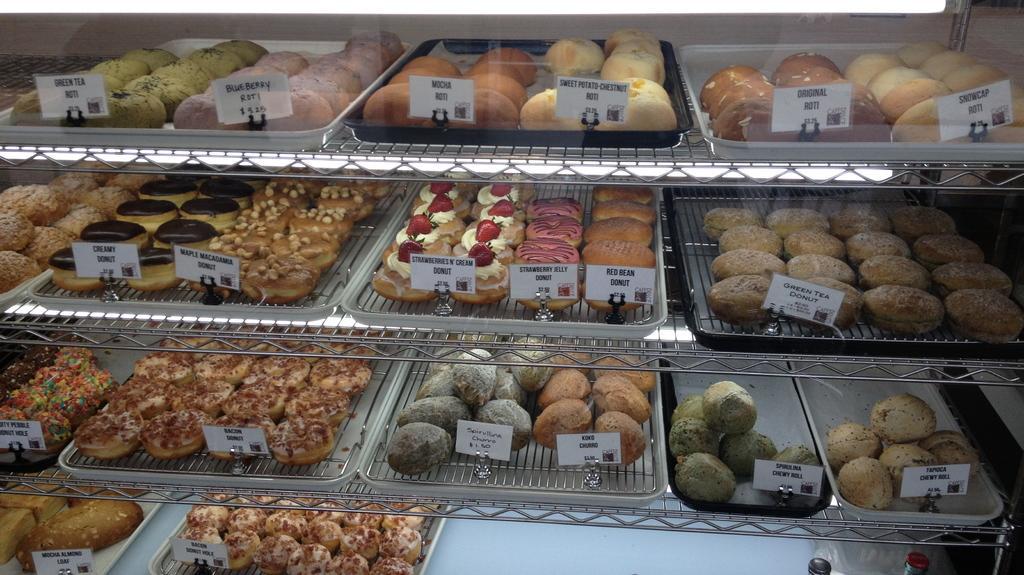Can you describe this image briefly? In this image we can see so many baked items are arranged with their tag price in the rack. 